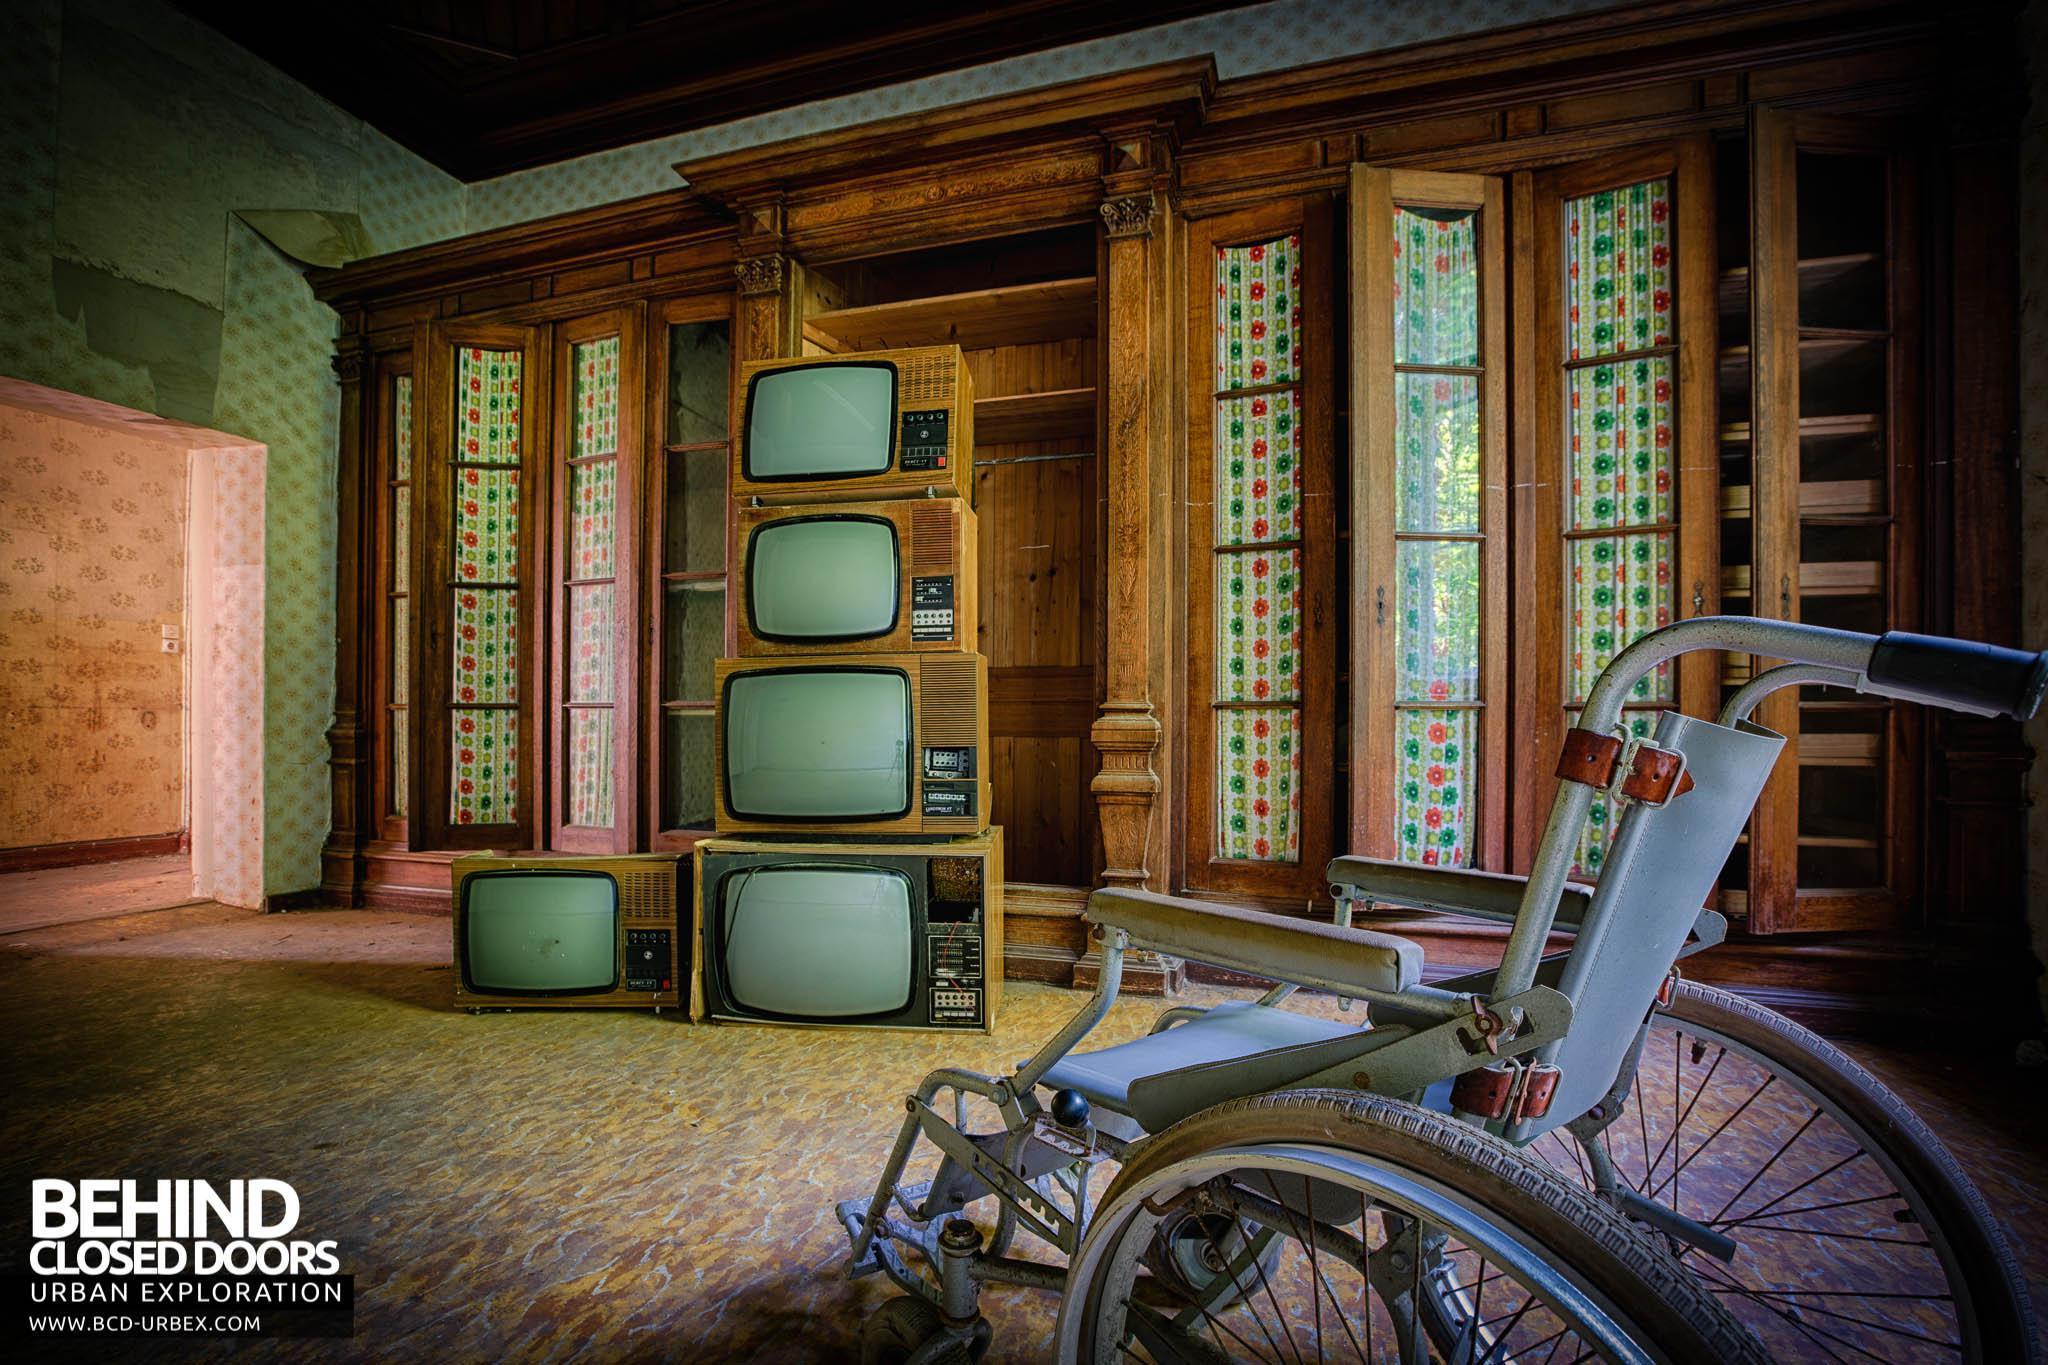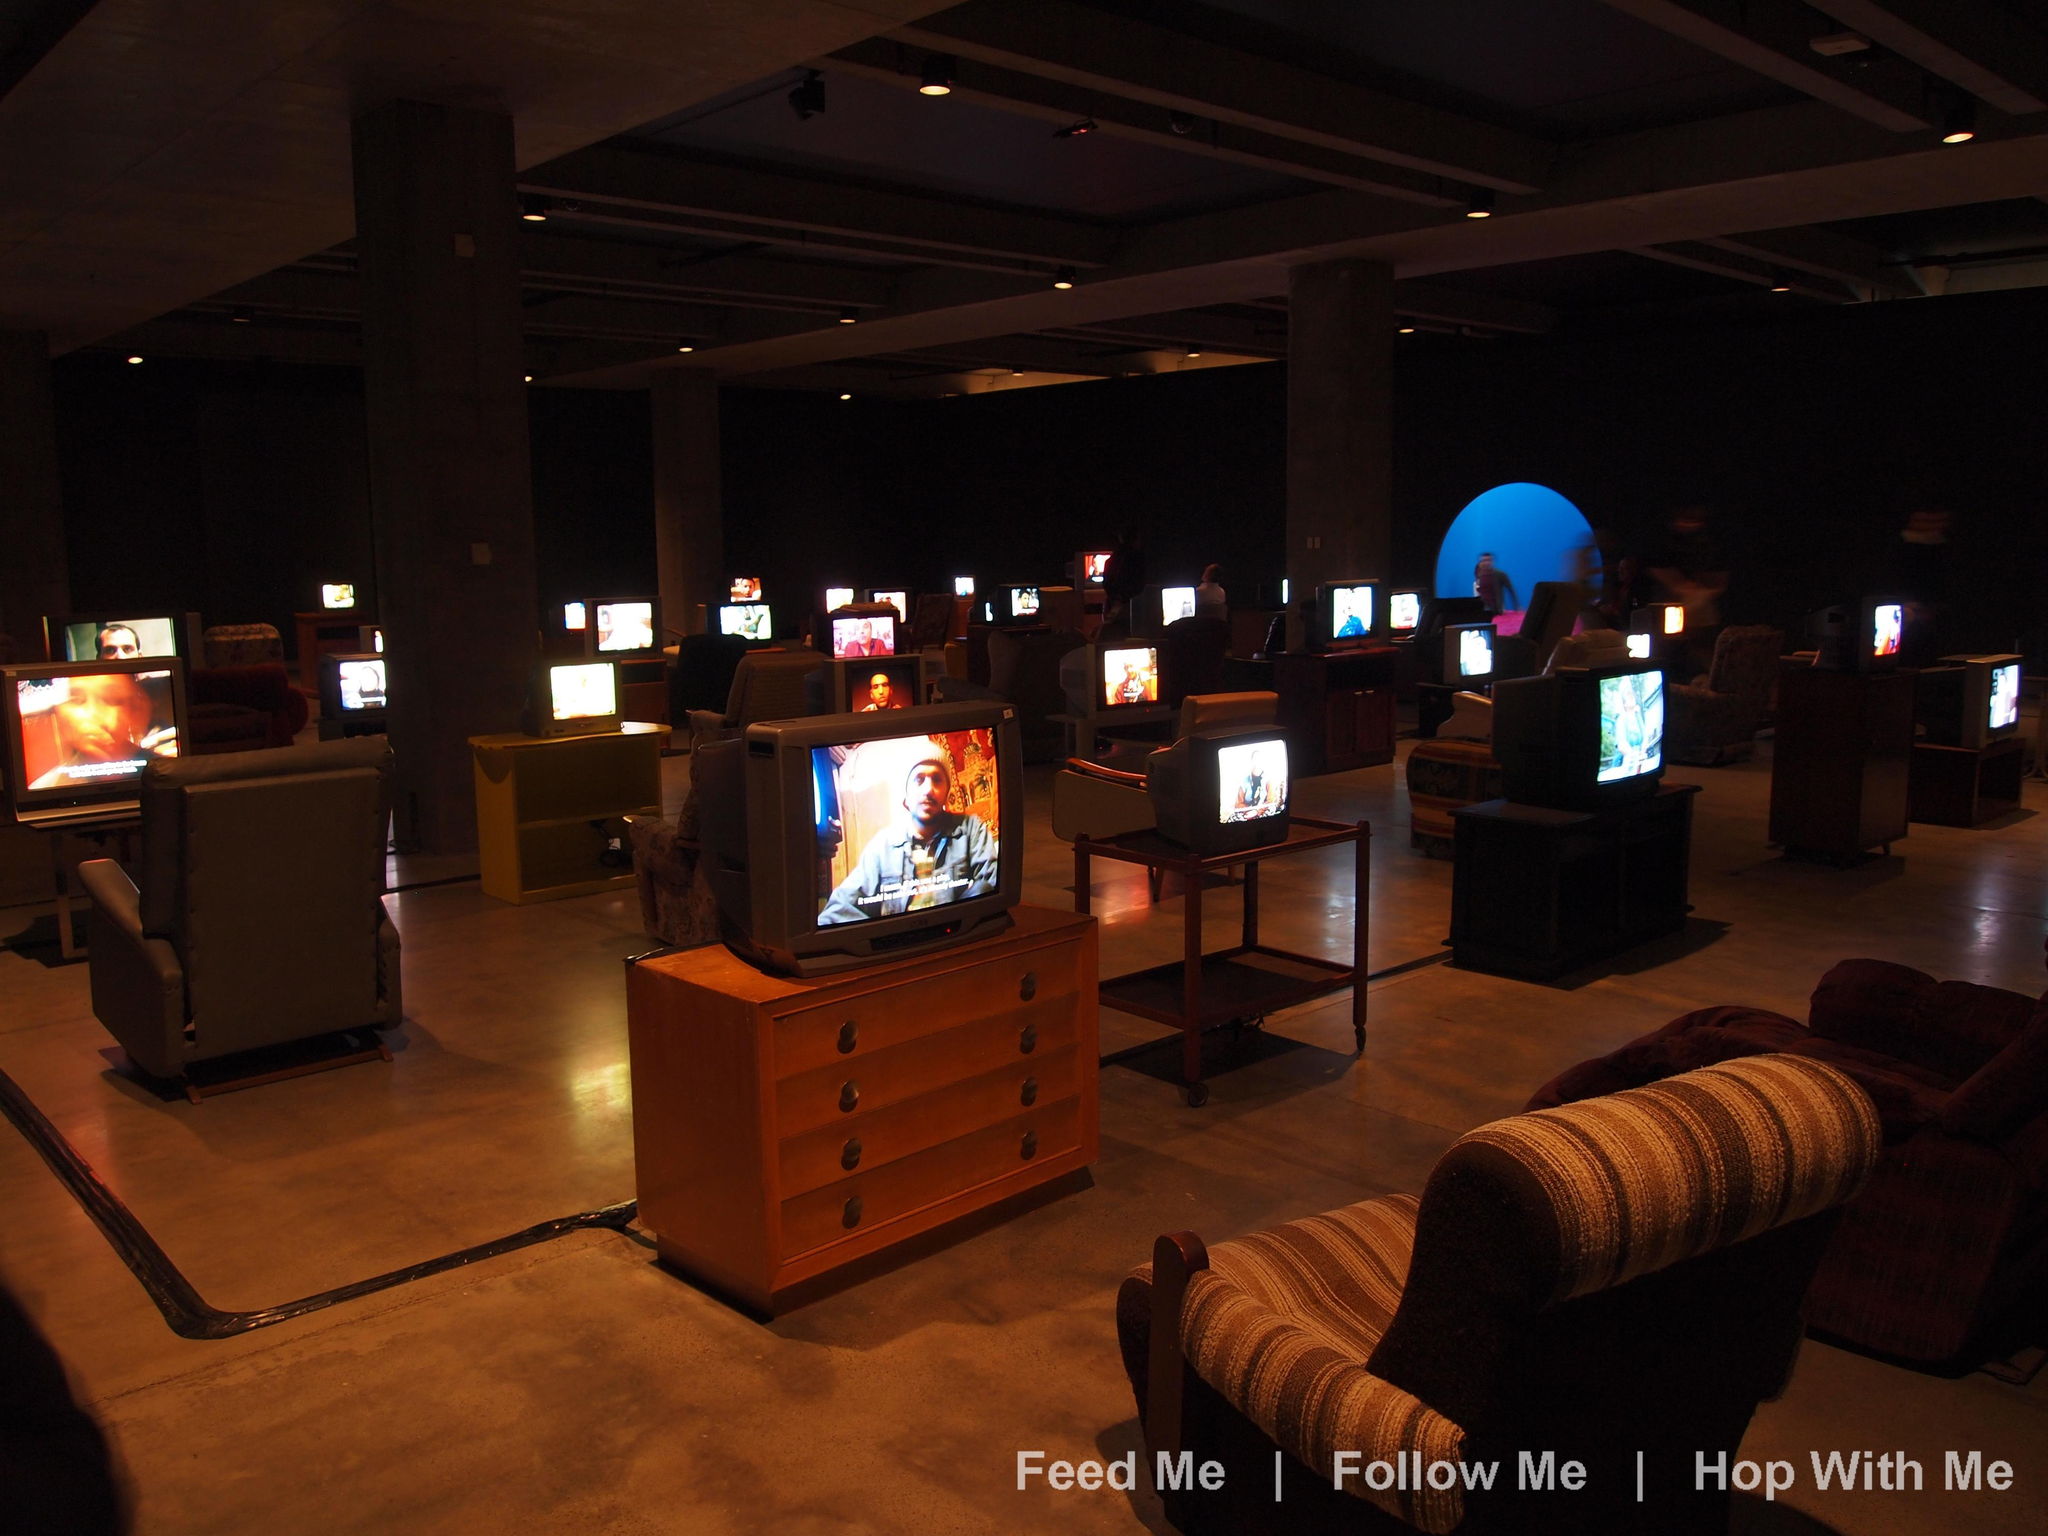The first image is the image on the left, the second image is the image on the right. Examine the images to the left and right. Is the description "At least one image shows upholstered chairs situated behind TVs with illuminated screens." accurate? Answer yes or no. Yes. The first image is the image on the left, the second image is the image on the right. Assess this claim about the two images: "Tube televisions are stacked together in the image on the left.". Correct or not? Answer yes or no. Yes. 